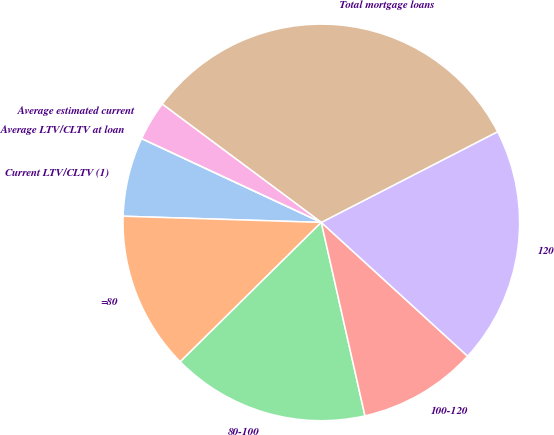Convert chart to OTSL. <chart><loc_0><loc_0><loc_500><loc_500><pie_chart><fcel>Current LTV/CLTV (1)<fcel>=80<fcel>80-100<fcel>100-120<fcel>120<fcel>Total mortgage loans<fcel>Average estimated current<fcel>Average LTV/CLTV at loan<nl><fcel>6.45%<fcel>12.9%<fcel>16.13%<fcel>9.68%<fcel>19.35%<fcel>32.26%<fcel>3.23%<fcel>0.0%<nl></chart> 